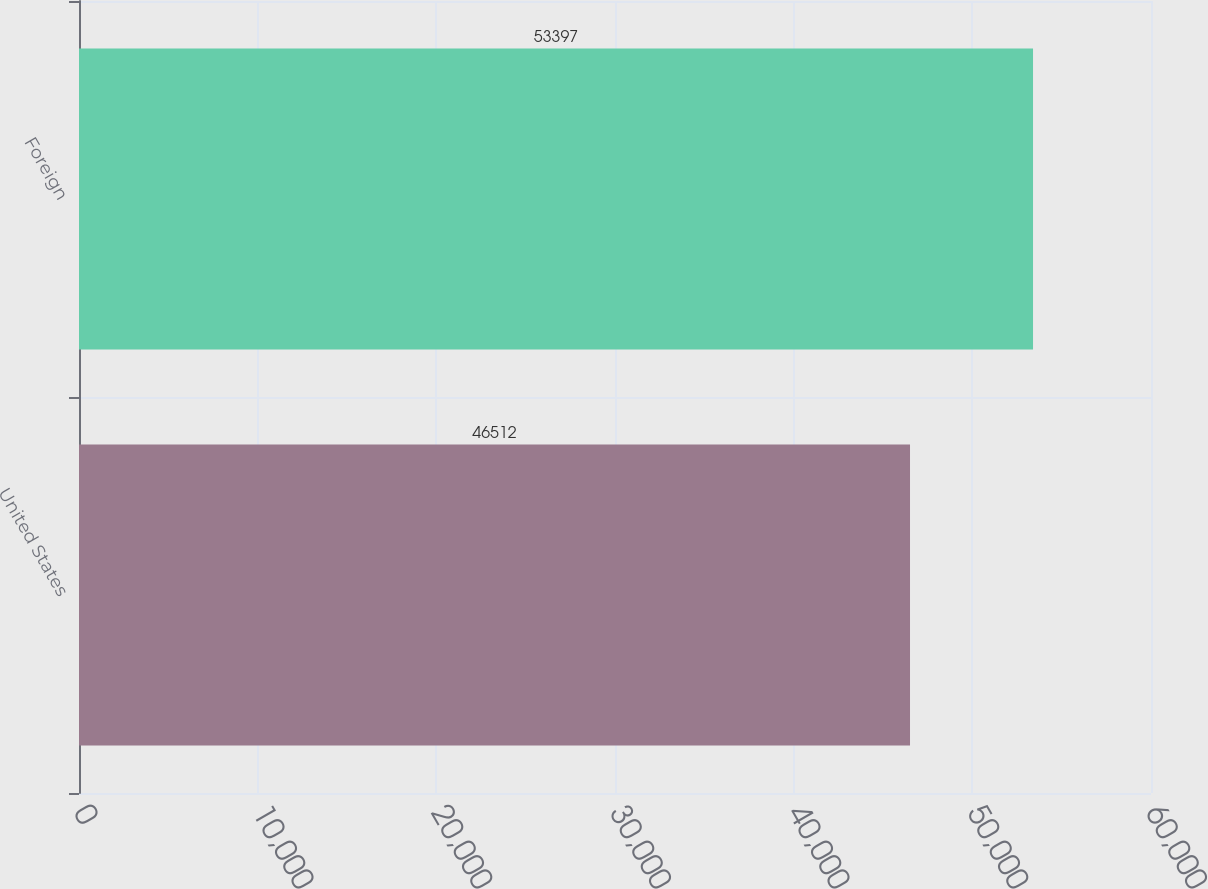Convert chart. <chart><loc_0><loc_0><loc_500><loc_500><bar_chart><fcel>United States<fcel>Foreign<nl><fcel>46512<fcel>53397<nl></chart> 